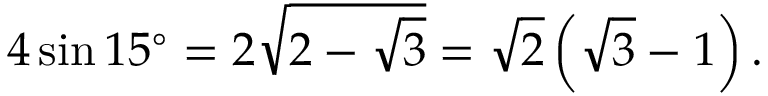Convert formula to latex. <formula><loc_0><loc_0><loc_500><loc_500>4 \sin 1 5 ^ { \circ } = 2 { \sqrt { 2 - { \sqrt { 3 } } } } = { \sqrt { 2 } } \left ( { \sqrt { 3 } } - 1 \right ) .</formula> 